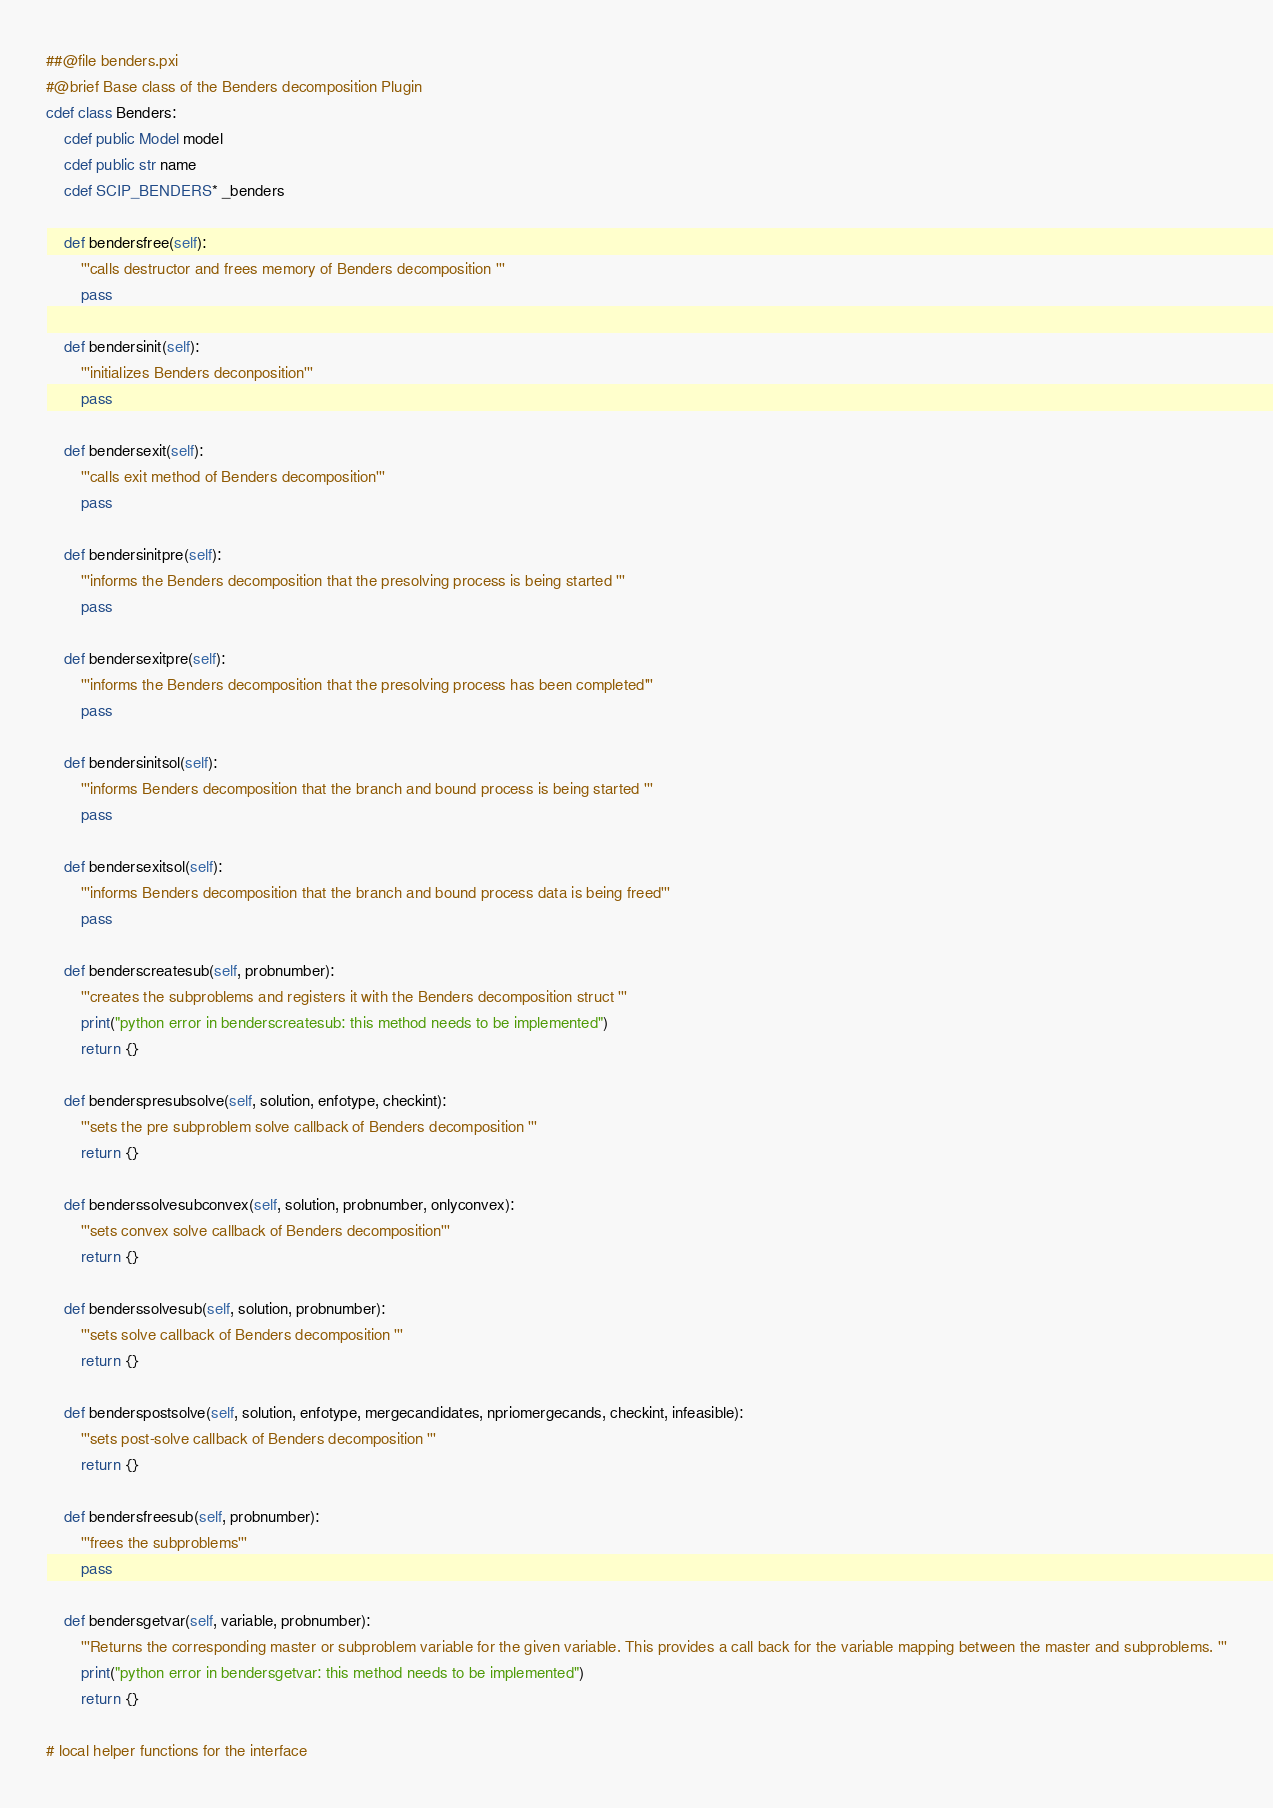<code> <loc_0><loc_0><loc_500><loc_500><_Cython_>##@file benders.pxi
#@brief Base class of the Benders decomposition Plugin
cdef class Benders:
    cdef public Model model
    cdef public str name
    cdef SCIP_BENDERS* _benders

    def bendersfree(self):
        '''calls destructor and frees memory of Benders decomposition '''
        pass

    def bendersinit(self):
        '''initializes Benders deconposition'''
        pass

    def bendersexit(self):
        '''calls exit method of Benders decomposition'''
        pass

    def bendersinitpre(self):
        '''informs the Benders decomposition that the presolving process is being started '''
        pass

    def bendersexitpre(self):
        '''informs the Benders decomposition that the presolving process has been completed'''
        pass

    def bendersinitsol(self):
        '''informs Benders decomposition that the branch and bound process is being started '''
        pass

    def bendersexitsol(self):
        '''informs Benders decomposition that the branch and bound process data is being freed'''
        pass

    def benderscreatesub(self, probnumber):
        '''creates the subproblems and registers it with the Benders decomposition struct '''
        print("python error in benderscreatesub: this method needs to be implemented")
        return {}

    def benderspresubsolve(self, solution, enfotype, checkint):
        '''sets the pre subproblem solve callback of Benders decomposition '''
        return {}

    def benderssolvesubconvex(self, solution, probnumber, onlyconvex):
        '''sets convex solve callback of Benders decomposition'''
        return {}

    def benderssolvesub(self, solution, probnumber):
        '''sets solve callback of Benders decomposition '''
        return {}

    def benderspostsolve(self, solution, enfotype, mergecandidates, npriomergecands, checkint, infeasible):
        '''sets post-solve callback of Benders decomposition '''
        return {}

    def bendersfreesub(self, probnumber):
        '''frees the subproblems'''
        pass

    def bendersgetvar(self, variable, probnumber):
        '''Returns the corresponding master or subproblem variable for the given variable. This provides a call back for the variable mapping between the master and subproblems. '''
        print("python error in bendersgetvar: this method needs to be implemented")
        return {}

# local helper functions for the interface</code> 